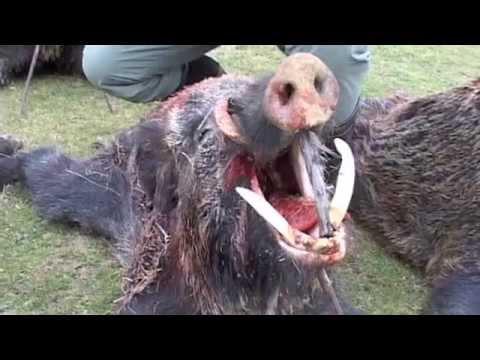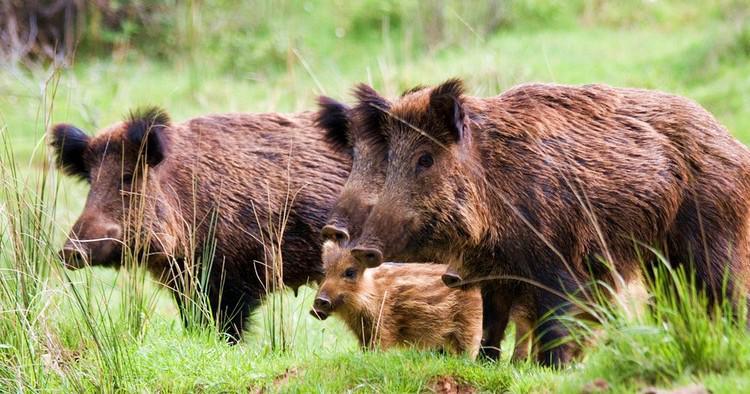The first image is the image on the left, the second image is the image on the right. Considering the images on both sides, is "The right image contains exactly one boar." valid? Answer yes or no. No. The first image is the image on the left, the second image is the image on the right. Given the left and right images, does the statement "Three adult wild pigs stand in green grass with at least one baby pig whose hair has distinctive stripes." hold true? Answer yes or no. Yes. 